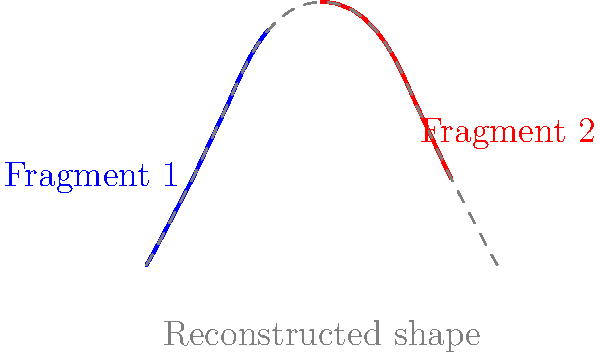In the topological reconstruction of a fragmented artifact, two pieces (blue and red) of an ancient vase have been discovered. Based on the curvature and alignment of these fragments, what is the most likely height-to-width ratio of the original vase, assuming it's symmetrical? To determine the height-to-width ratio of the original vase, we need to follow these steps:

1. Analyze the curvature of the fragments:
   - The blue fragment shows the base and lower part of the vase.
   - The red fragment represents the upper part and rim of the vase.

2. Observe the alignment and symmetry:
   - The fragments suggest a symmetrical shape around a vertical axis.

3. Estimate the full shape:
   - The dashed gray line shows the reconstructed shape based on the fragments.

4. Calculate the height-to-width ratio:
   - Height: From the base to the highest point of the reconstructed shape.
   - Width: The maximum horizontal distance of the reconstructed shape.

5. Measure the dimensions:
   - Height ≈ 3 units
   - Width ≈ 4 units

6. Calculate the ratio:
   $\text{Height-to-width ratio} = \frac{\text{Height}}{\text{Width}} = \frac{3}{4} = 0.75$

Therefore, the most likely height-to-width ratio of the original vase is approximately $3:4$ or $0.75:1$.
Answer: $0.75:1$ 